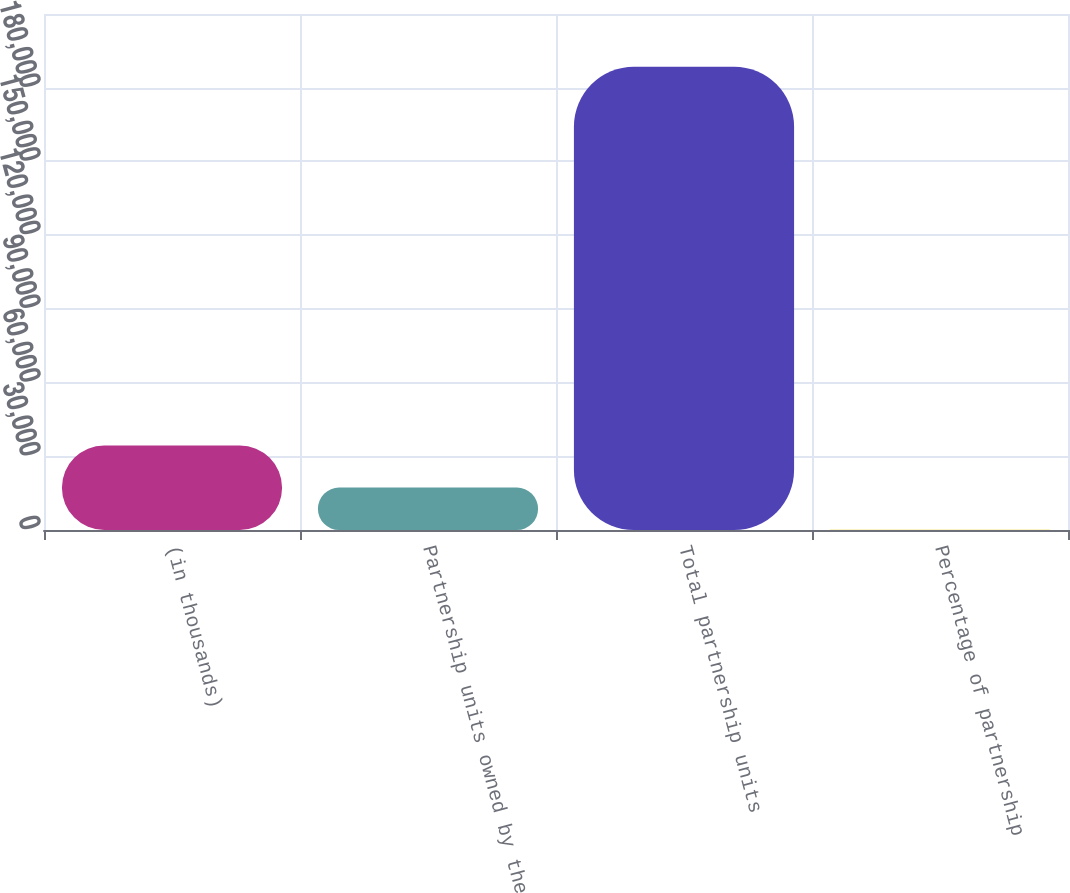Convert chart to OTSL. <chart><loc_0><loc_0><loc_500><loc_500><bar_chart><fcel>(in thousands)<fcel>Partnership units owned by the<fcel>Total partnership units<fcel>Percentage of partnership<nl><fcel>34422.8<fcel>17261.3<fcel>188527<fcel>99.8<nl></chart> 